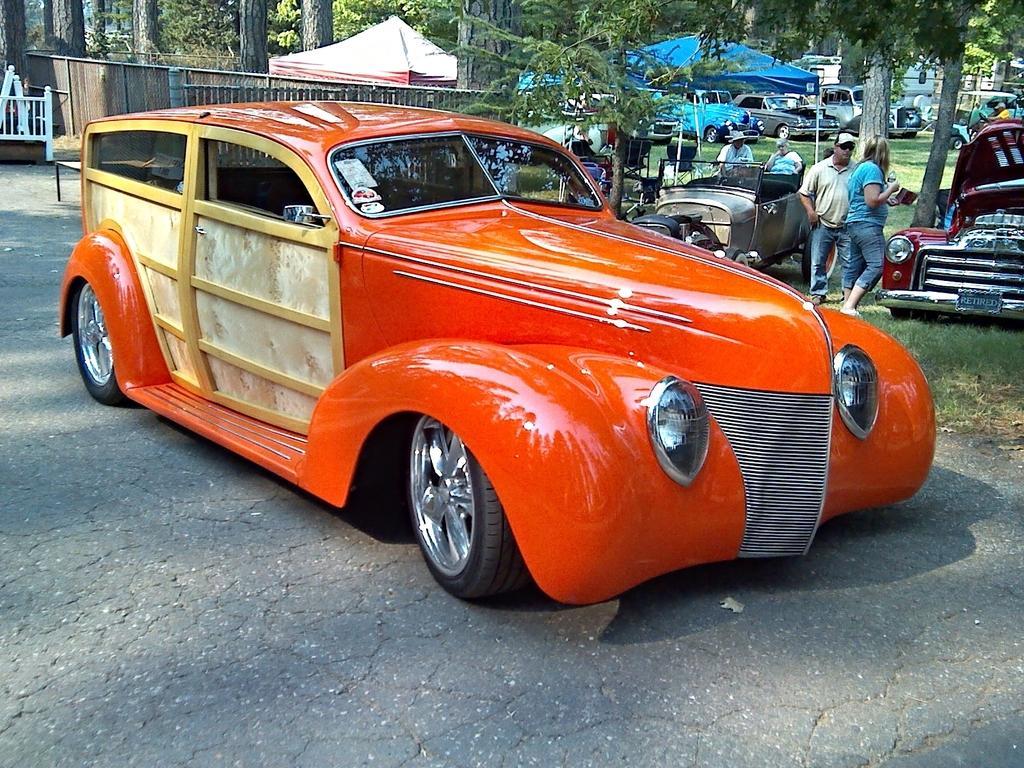Could you give a brief overview of what you see in this image? In front of the image there is a car, behind the car there are a few cars parked on the grass surface and there are a few people around it, in the background of the image there are tents and trees. 